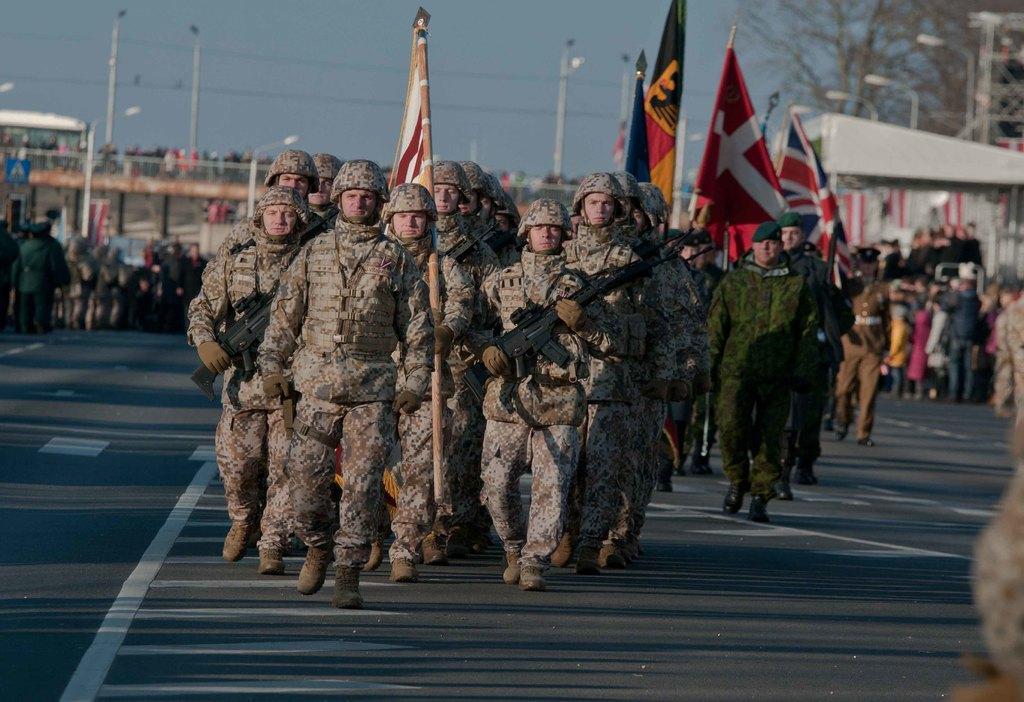Can you describe this image briefly? In this picture, we can see a few people, and among them we can see a few soldiers holding some objects like flags, guns, and we can see the ground, poles, lights, and the blurred background with trees, sheds, and the sky. 